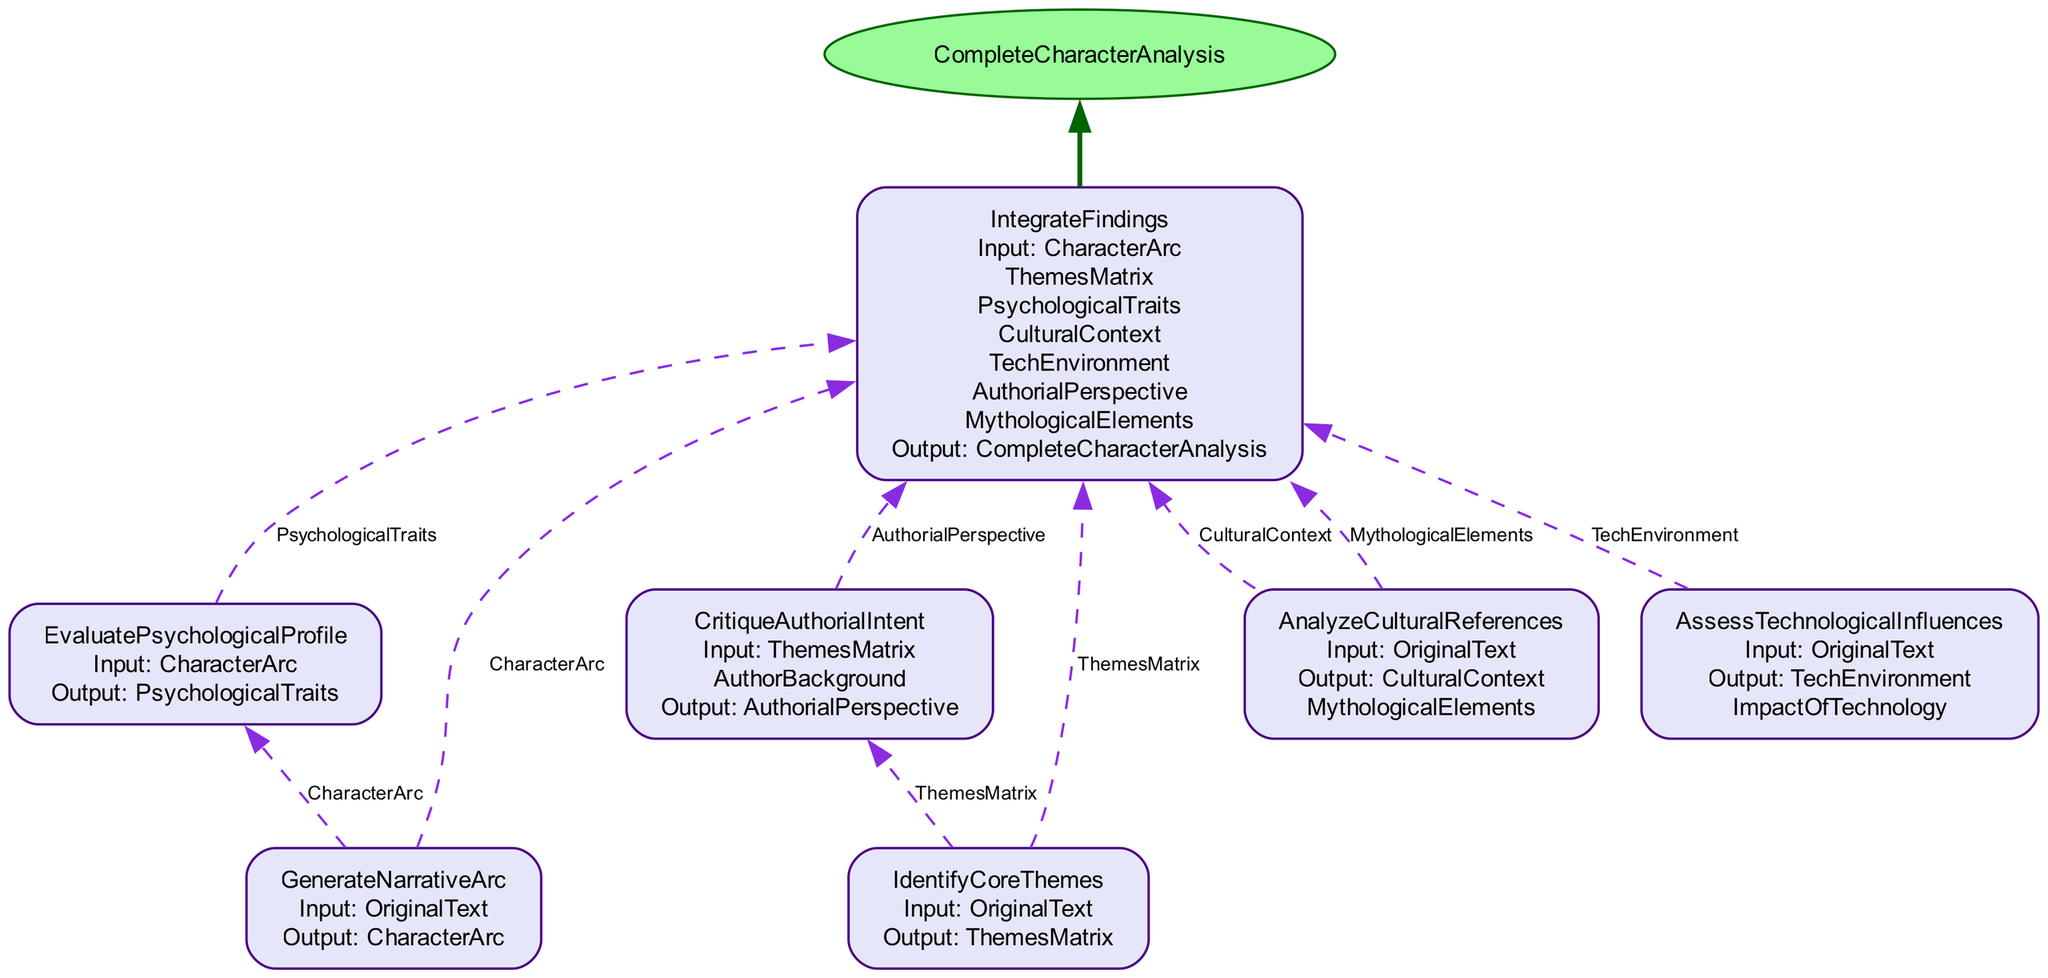What is the final output of the function? The final output, as indicated in the diagram, is labeled as "CompleteCharacterAnalysis." This is shown clearly at the top of the flowchart.
Answer: CompleteCharacterAnalysis How many steps are involved in the function? There are six distinct steps outlined in the diagram, each representing a phase in the character development analysis process.
Answer: Six What is the first step in the function? The first step is "GenerateNarrativeArc," which is the initial action taken when processing the original text.
Answer: GenerateNarrativeArc Which node outputs "PsychologicalTraits"? The "EvaluatePsychologicalProfile" step directly outputs "PsychologicalTraits," as indicated by its output listing in the diagram.
Answer: EvaluatePsychologicalProfile Which inputs are required by the "IntegrateFindings" step? The "IntegrateFindings" step requires seven inputs: "CharacterArc," "ThemesMatrix," "PsychologicalTraits," "CulturalContext," "TechEnvironment," "AuthorialPerspective," and "MythologicalElements."
Answer: Seven inputs What outputs are produced from the "AssessTechnologicalInfluences" step? The "AssessTechnologicalInfluences" step produces two outputs: "TechEnvironment" and "ImpactOfTechnology," as listed in the step's output section.
Answer: TechEnvironment, ImpactOfTechnology Which steps depend on the output of "AnalyzeCulturalReferences"? The output from "AnalyzeCulturalReferences," which includes "CulturalContext" and "MythologicalElements," feeds into the "IntegrateFindings" step. This dependence can be seen from the edges connecting the steps.
Answer: IntegrateFindings What is the relationship between "IdentifyCoreThemes" and "CritiqueAuthorialIntent"? "IdentifyCoreThemes" provides an output called "ThemesMatrix," which serves as an input for the "CritiqueAuthorialIntent." This relationship is clearly indicated by the connecting edge in the diagram.
Answer: ThemesMatrix What color is the final output node? The final output node, "CompleteCharacterAnalysis," is filled with a color represented as "#98FB98," which indicates its status as the final output in the function.
Answer: #98FB98 